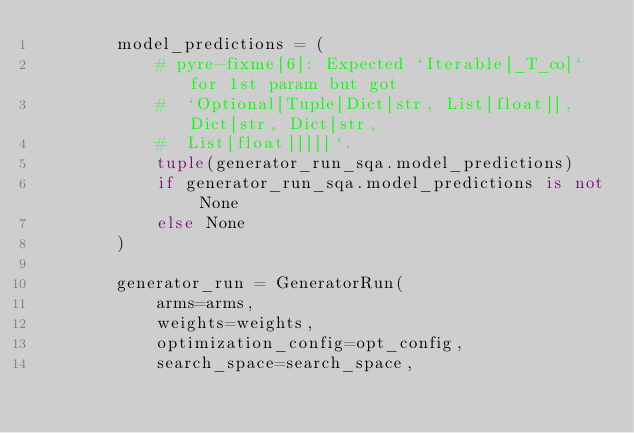Convert code to text. <code><loc_0><loc_0><loc_500><loc_500><_Python_>        model_predictions = (
            # pyre-fixme[6]: Expected `Iterable[_T_co]` for 1st param but got
            #  `Optional[Tuple[Dict[str, List[float]], Dict[str, Dict[str,
            #  List[float]]]]]`.
            tuple(generator_run_sqa.model_predictions)
            if generator_run_sqa.model_predictions is not None
            else None
        )

        generator_run = GeneratorRun(
            arms=arms,
            weights=weights,
            optimization_config=opt_config,
            search_space=search_space,</code> 